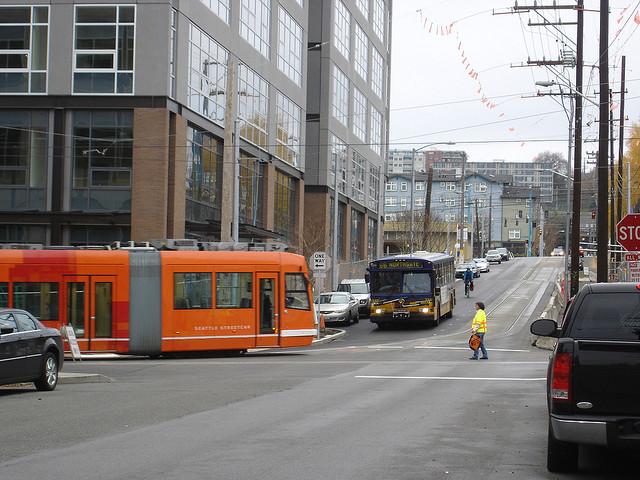Does the street need to be fixed?
Keep it brief. No. Do you see a stop sign?
Short answer required. Yes. What is the profession of the person in the bottom right?
Answer briefly. Crossing guard. What color is the bus to the left?
Give a very brief answer. Orange. Who crosses the street?
Give a very brief answer. Woman. 